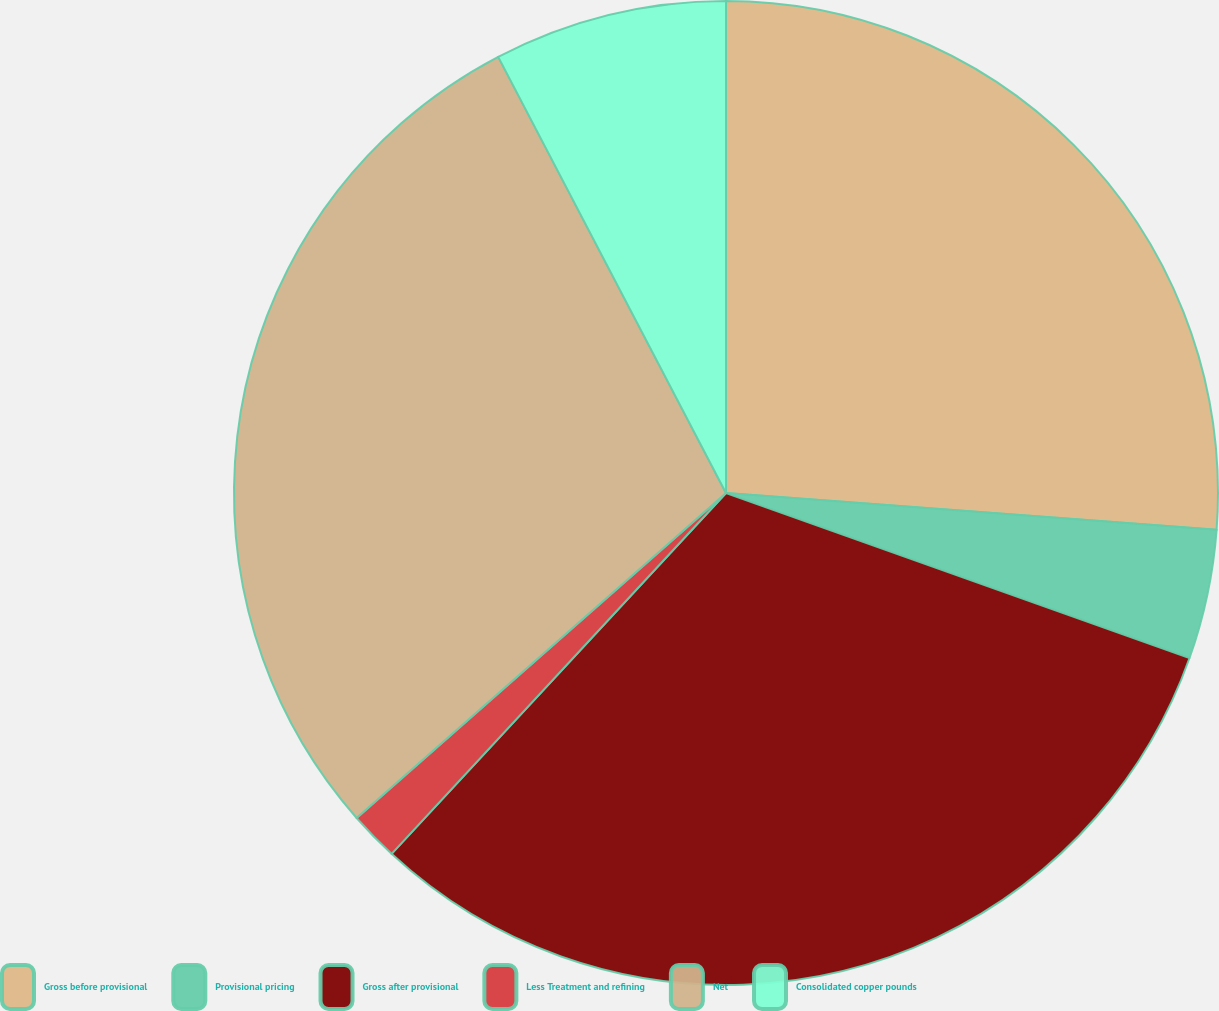Convert chart. <chart><loc_0><loc_0><loc_500><loc_500><pie_chart><fcel>Gross before provisional<fcel>Provisional pricing<fcel>Gross after provisional<fcel>Less Treatment and refining<fcel>Net<fcel>Consolidated copper pounds<nl><fcel>26.19%<fcel>4.25%<fcel>31.45%<fcel>1.62%<fcel>28.82%<fcel>7.66%<nl></chart> 